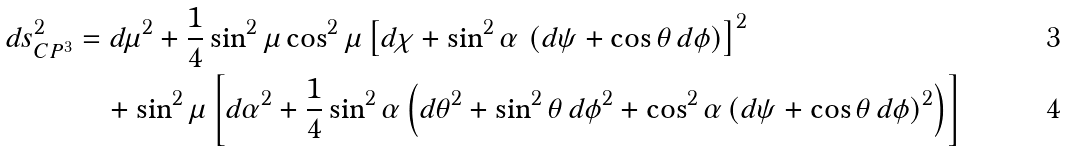<formula> <loc_0><loc_0><loc_500><loc_500>d s _ { C P ^ { 3 } } ^ { 2 } & = d \mu ^ { 2 } + \frac { 1 } { 4 } \sin ^ { 2 } \mu \cos ^ { 2 } \mu \left [ d \chi + \sin ^ { 2 } \alpha \, \left ( d \psi + \cos \theta \, d \phi \right ) \right ] ^ { 2 } \\ & \quad + \sin ^ { 2 } \mu \left [ d \alpha ^ { 2 } + \frac { 1 } { 4 } \sin ^ { 2 } \alpha \left ( d \theta ^ { 2 } + \sin ^ { 2 } \theta \, d \phi ^ { 2 } + \cos ^ { 2 } \alpha \left ( d \psi + \cos \theta \, d \phi \right ) ^ { 2 } \right ) \right ]</formula> 